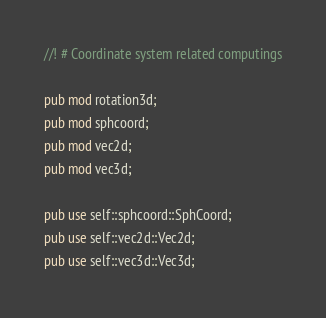Convert code to text. <code><loc_0><loc_0><loc_500><loc_500><_Rust_>//! # Coordinate system related computings

pub mod rotation3d;
pub mod sphcoord;
pub mod vec2d;
pub mod vec3d;

pub use self::sphcoord::SphCoord;
pub use self::vec2d::Vec2d;
pub use self::vec3d::Vec3d;
</code> 